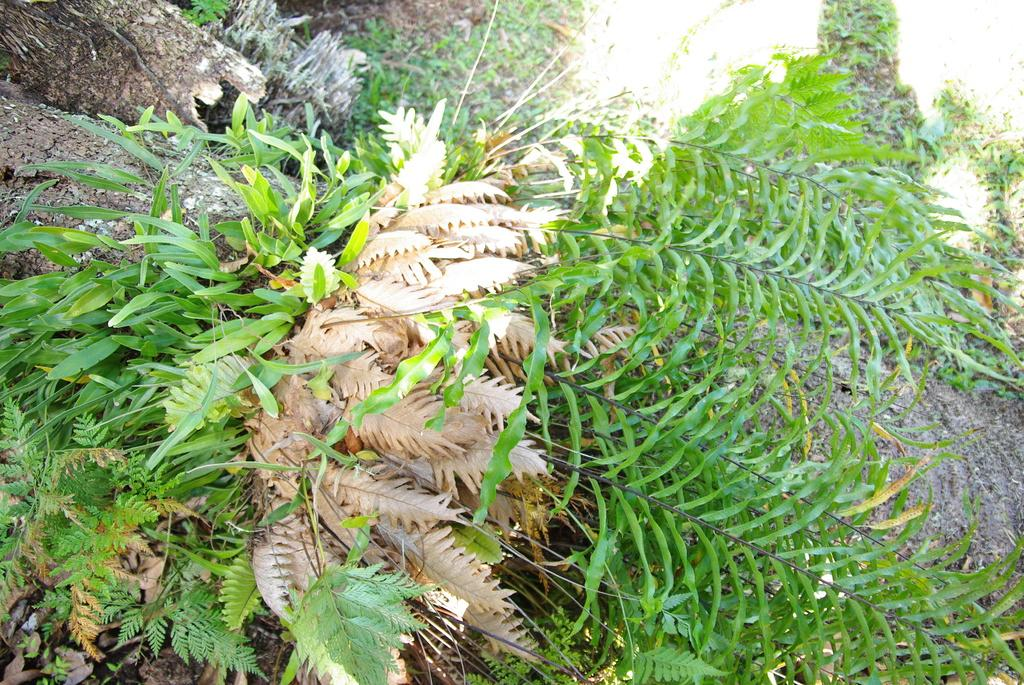What type of objects can be seen in the image? There are trunks in the image. What else can be found on the ground in the image? There are plants on the ground in the image. What time is the clock showing in the image? There is no clock present in the image, so it is not possible to determine the time. 